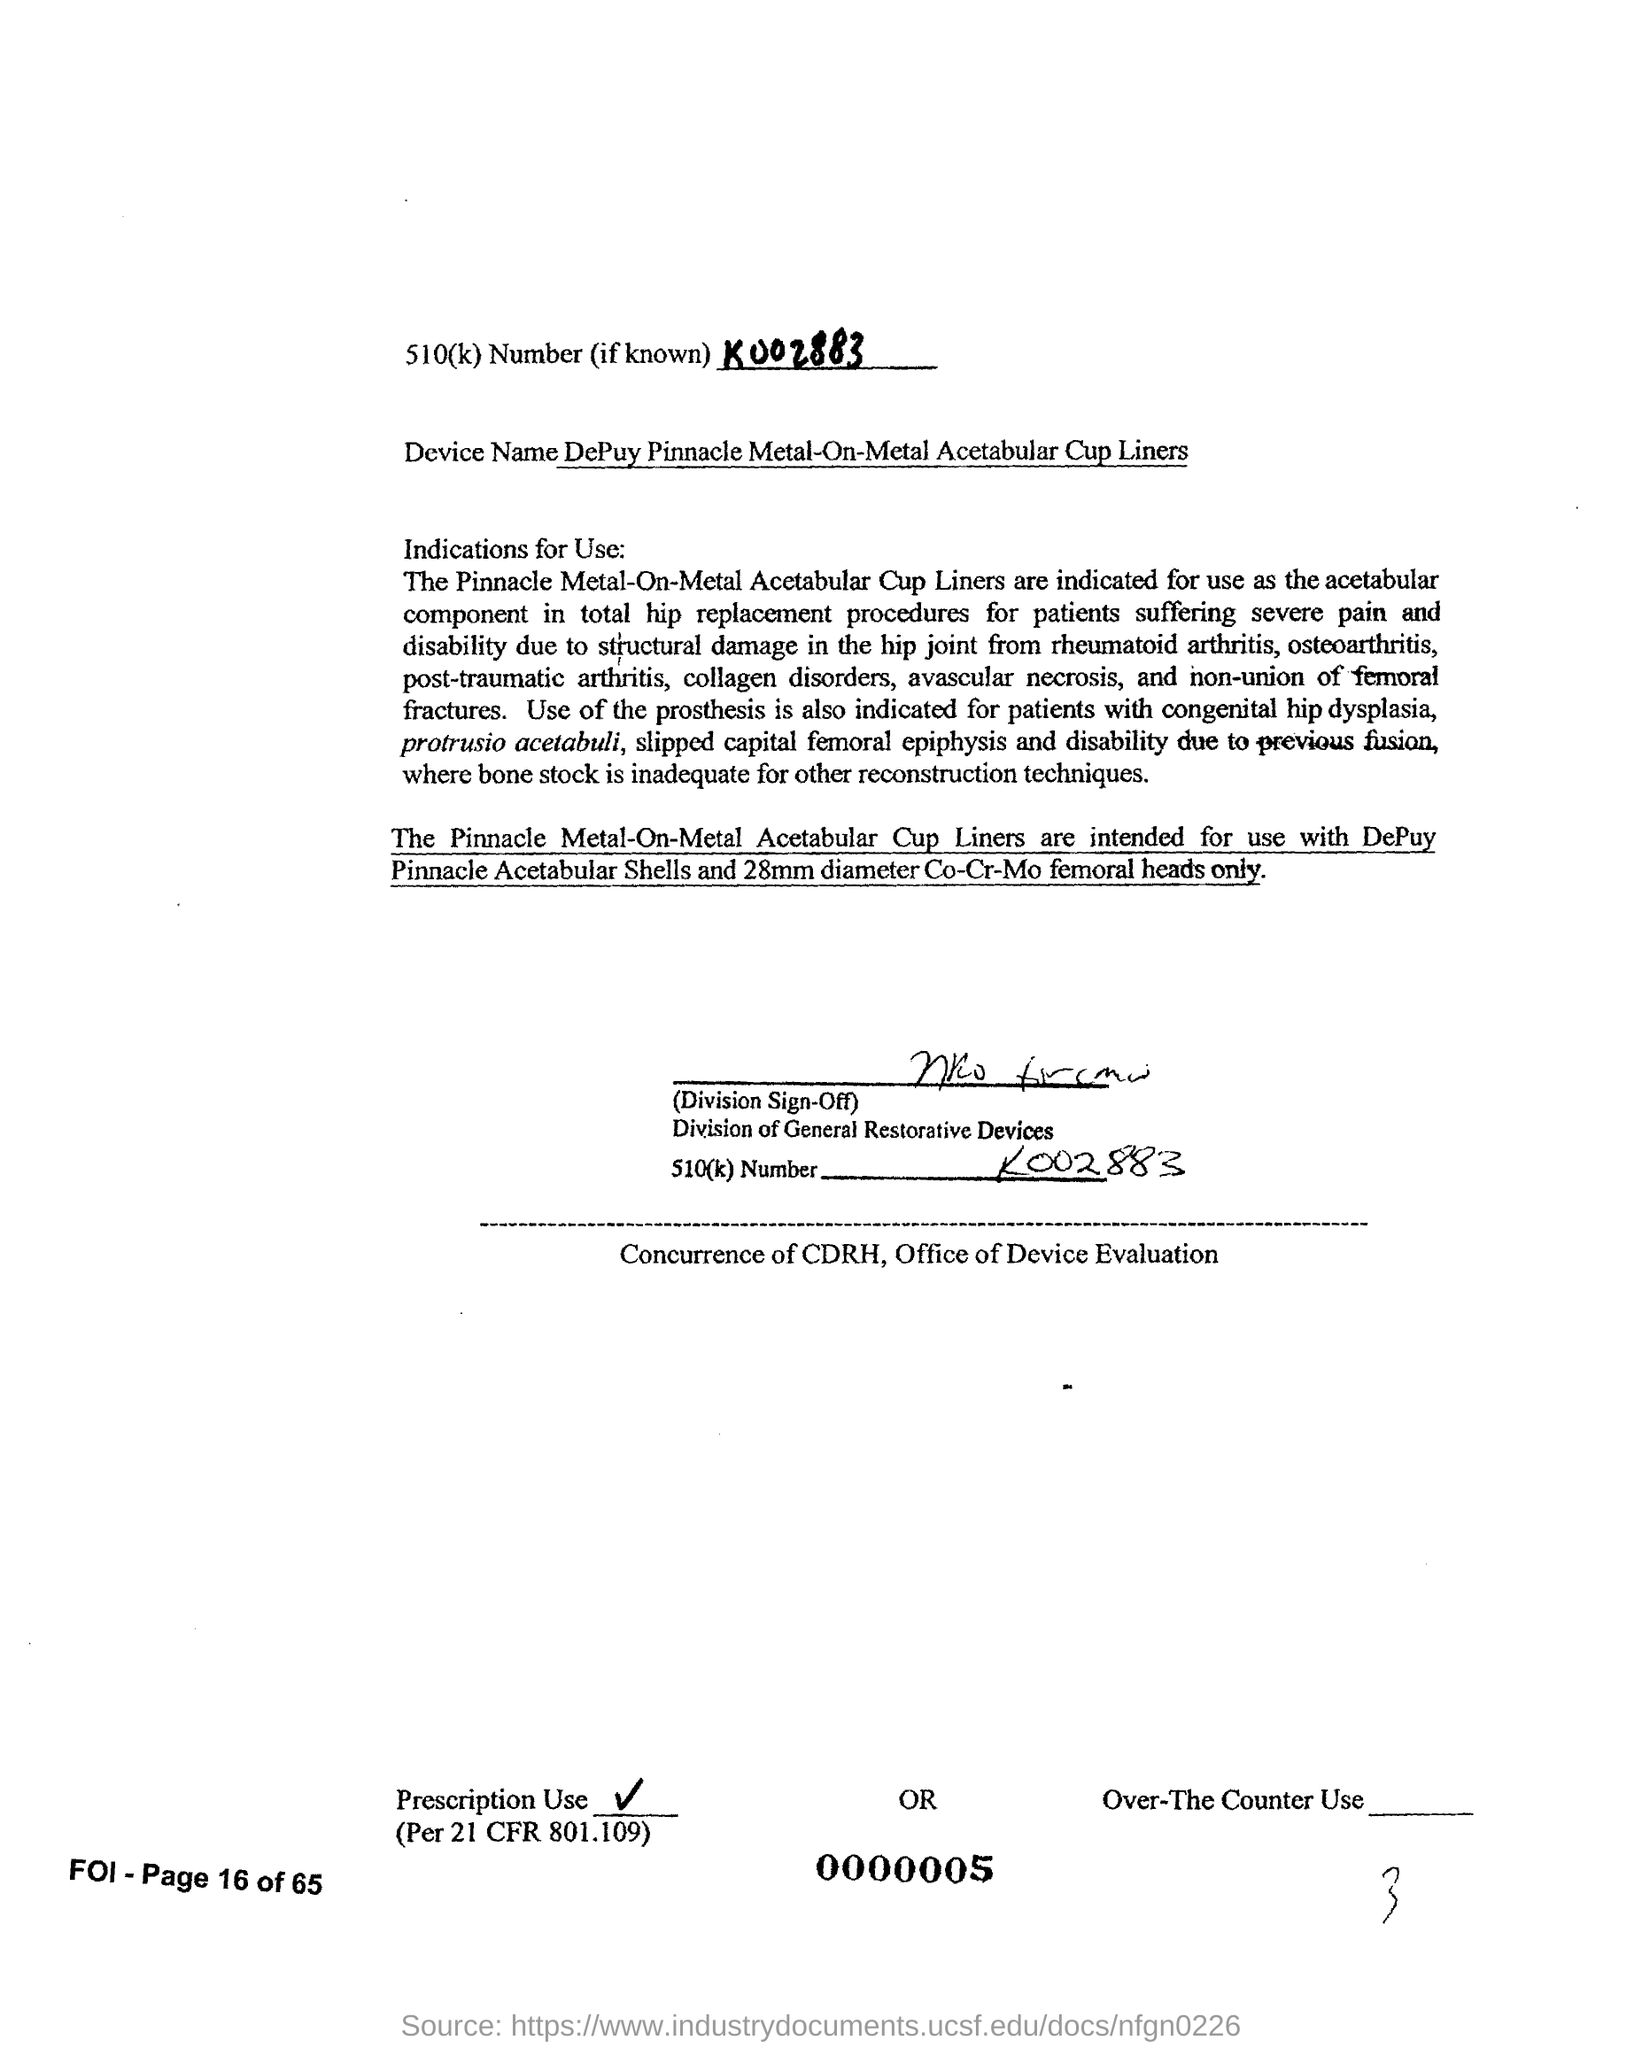Highlight a few significant elements in this photo. The device in question is a DePuy Pinnacle Metal-On-Metal Acetabular Cup Liners. The 510(k) number is a unique identifier assigned to medical devices by the U.S. Food and Drug Administration (FDA) to indicate that the device has been deemed to be substantially equivalent to a previously approved device. The 510(k) number is typically displayed on the device or its packaging and is preceded by the letters "k" and a series of numbers and letters. For example, the 510(k) number "k002883..." would indicate that the device is substantially equivalent to a previously approved device and has been assigned the 510(k) number "k002883..." by the FDA. 